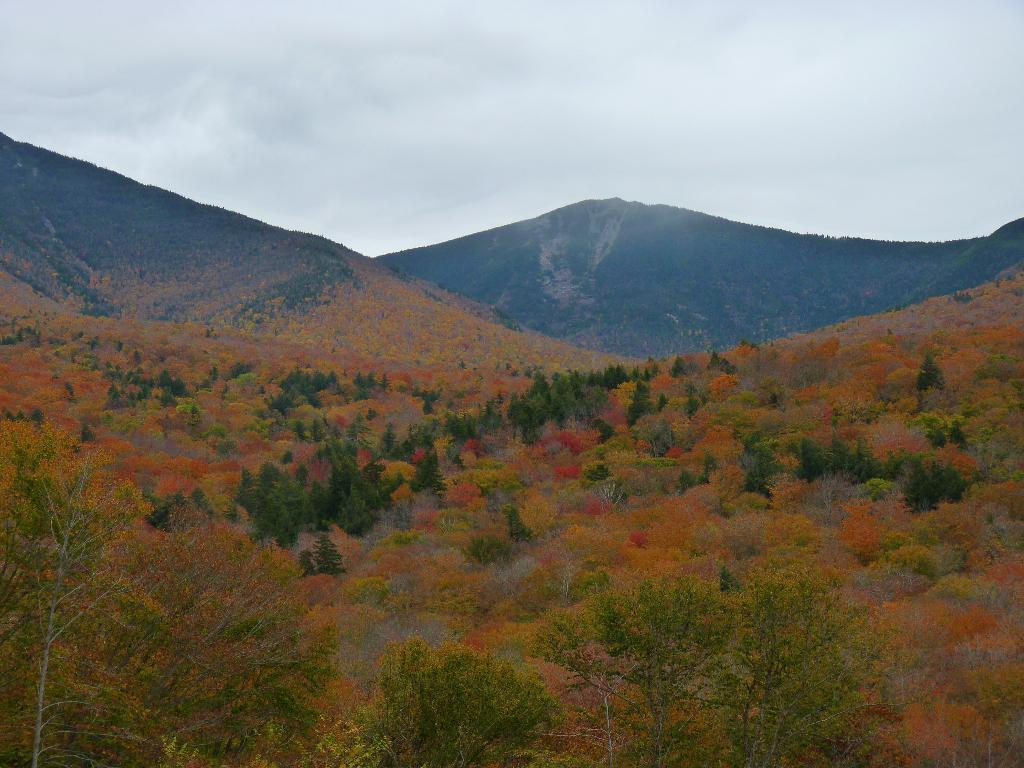What type of vegetation can be seen in the image? There are trees in the image. What is visible in the background of the image? There is a mountain and the sky visible in the background of the image. How many toes can be seen on the carriage in the image? There is no carriage present in the image, so it is not possible to determine the number of toes on it. 